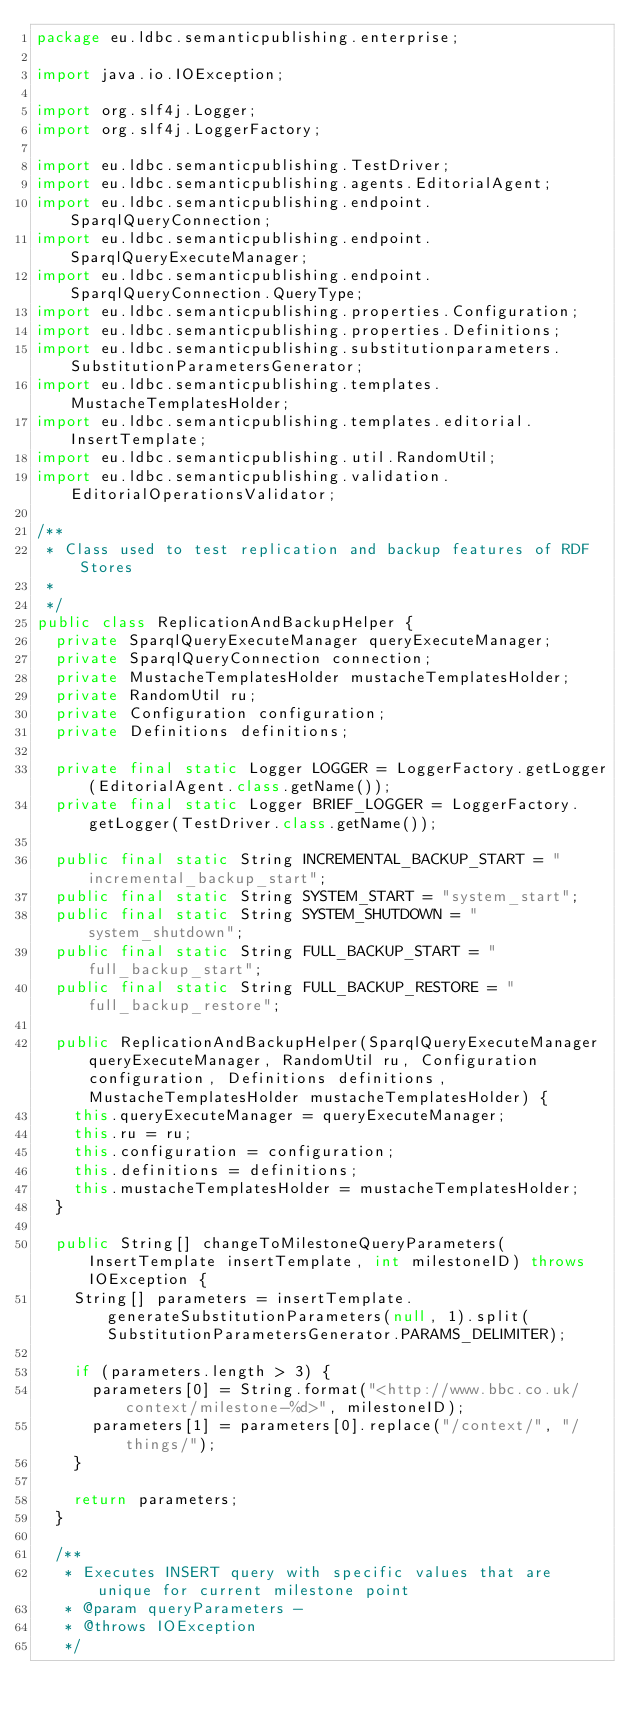Convert code to text. <code><loc_0><loc_0><loc_500><loc_500><_Java_>package eu.ldbc.semanticpublishing.enterprise;

import java.io.IOException;

import org.slf4j.Logger;
import org.slf4j.LoggerFactory;

import eu.ldbc.semanticpublishing.TestDriver;
import eu.ldbc.semanticpublishing.agents.EditorialAgent;
import eu.ldbc.semanticpublishing.endpoint.SparqlQueryConnection;
import eu.ldbc.semanticpublishing.endpoint.SparqlQueryExecuteManager;
import eu.ldbc.semanticpublishing.endpoint.SparqlQueryConnection.QueryType;
import eu.ldbc.semanticpublishing.properties.Configuration;
import eu.ldbc.semanticpublishing.properties.Definitions;
import eu.ldbc.semanticpublishing.substitutionparameters.SubstitutionParametersGenerator;
import eu.ldbc.semanticpublishing.templates.MustacheTemplatesHolder;
import eu.ldbc.semanticpublishing.templates.editorial.InsertTemplate;
import eu.ldbc.semanticpublishing.util.RandomUtil;
import eu.ldbc.semanticpublishing.validation.EditorialOperationsValidator;

/**
 * Class used to test replication and backup features of RDF Stores
 *
 */
public class ReplicationAndBackupHelper {
	private SparqlQueryExecuteManager queryExecuteManager;
	private SparqlQueryConnection connection;
	private MustacheTemplatesHolder mustacheTemplatesHolder;
	private RandomUtil ru;
	private Configuration configuration;
	private Definitions definitions;
	
	private final static Logger LOGGER = LoggerFactory.getLogger(EditorialAgent.class.getName());
	private final static Logger BRIEF_LOGGER = LoggerFactory.getLogger(TestDriver.class.getName());
	
	public final static String INCREMENTAL_BACKUP_START = "incremental_backup_start";
	public final static String SYSTEM_START = "system_start";
	public final static String SYSTEM_SHUTDOWN = "system_shutdown";
	public final static String FULL_BACKUP_START = "full_backup_start";
	public final static String FULL_BACKUP_RESTORE = "full_backup_restore";
	
	public ReplicationAndBackupHelper(SparqlQueryExecuteManager queryExecuteManager, RandomUtil ru, Configuration configuration, Definitions definitions, MustacheTemplatesHolder mustacheTemplatesHolder) {
		this.queryExecuteManager = queryExecuteManager;
		this.ru = ru;
		this.configuration = configuration;
		this.definitions = definitions;
		this.mustacheTemplatesHolder = mustacheTemplatesHolder;
	}
	
	public String[] changeToMilestoneQueryParameters(InsertTemplate insertTemplate, int milestoneID) throws IOException {
		String[] parameters = insertTemplate.generateSubstitutionParameters(null, 1).split(SubstitutionParametersGenerator.PARAMS_DELIMITER);
		
		if (parameters.length > 3) {
			parameters[0] = String.format("<http://www.bbc.co.uk/context/milestone-%d>", milestoneID);
			parameters[1] = parameters[0].replace("/context/", "/things/");
		}
		
		return parameters;
	}
	
	/**
	 * Executes INSERT query with specific values that are unique for current milestone point
	 * @param queryParameters - 
	 * @throws IOException 
	 */</code> 